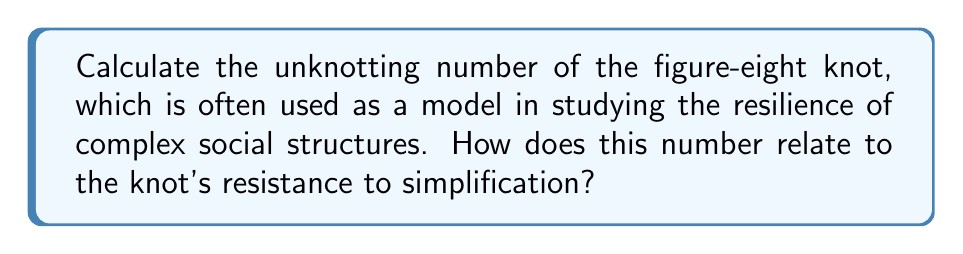Can you solve this math problem? To calculate the unknotting number of the figure-eight knot, we follow these steps:

1. Identify the knot: The figure-eight knot is also known as the 4₁ knot in the Alexander-Briggs notation.

2. Examine crossing changes: The unknotting number is the minimum number of crossing changes required to transform the knot into the unknot (trivial knot).

3. Analyze the knot diagram:
   [asy]
   import geometry;
   
   pair A = (0,0), B = (1,1), C = (2,0), D = (1,-1);
   path p = A..controls (0.5,0.5) and (0.5,0.5)..B..controls (1.5,1.5) and (1.5,1.5)..C
            ..controls (1.5,-0.5) and (1.5,-0.5)..D..controls (0.5,-0.5) and (0.5,-0.5)..A;
   
   draw(p, linewidth(1));
   draw(A--C, dashed);
   draw(B--D, dashed);
   
   label("A", A, SW);
   label("B", B, NE);
   label("C", C, SE);
   label("D", D, SW);
   [/asy]

4. Determine the minimal number of crossing changes:
   - The figure-eight knot has four crossings in its minimal diagram.
   - Changing any one crossing does not result in the unknot.
   - Changing two specific crossings (either the pair at A and C, or the pair at B and D) results in the unknot.

5. Conclude: The unknotting number of the figure-eight knot is 1.

6. Interpret the result:
   - A low unknotting number (1) indicates that the knot is relatively simple to unknot.
   - However, it still requires at least one crossing change, showing some resistance to simplification.
   - In the context of social structures, this suggests a balance between complexity and the potential for change or simplification.
Answer: 1 